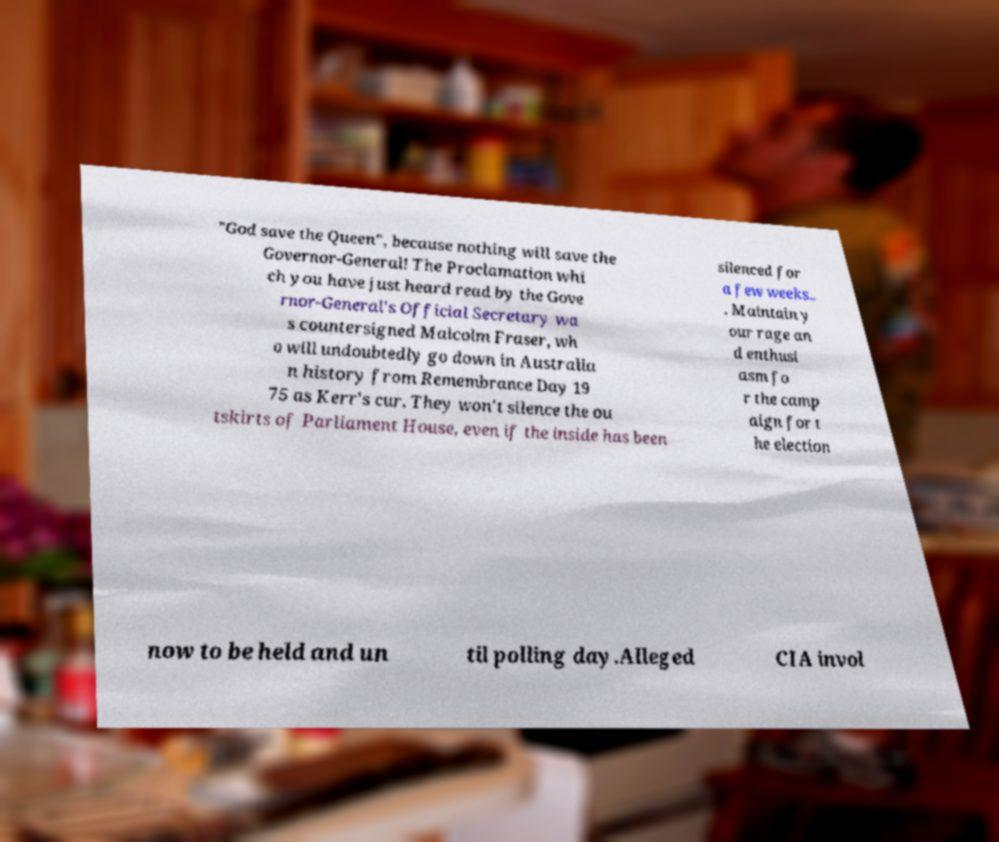For documentation purposes, I need the text within this image transcribed. Could you provide that? "God save the Queen", because nothing will save the Governor-General! The Proclamation whi ch you have just heard read by the Gove rnor-General's Official Secretary wa s countersigned Malcolm Fraser, wh o will undoubtedly go down in Australia n history from Remembrance Day 19 75 as Kerr's cur. They won't silence the ou tskirts of Parliament House, even if the inside has been silenced for a few weeks.. . Maintain y our rage an d enthusi asm fo r the camp aign for t he election now to be held and un til polling day.Alleged CIA invol 